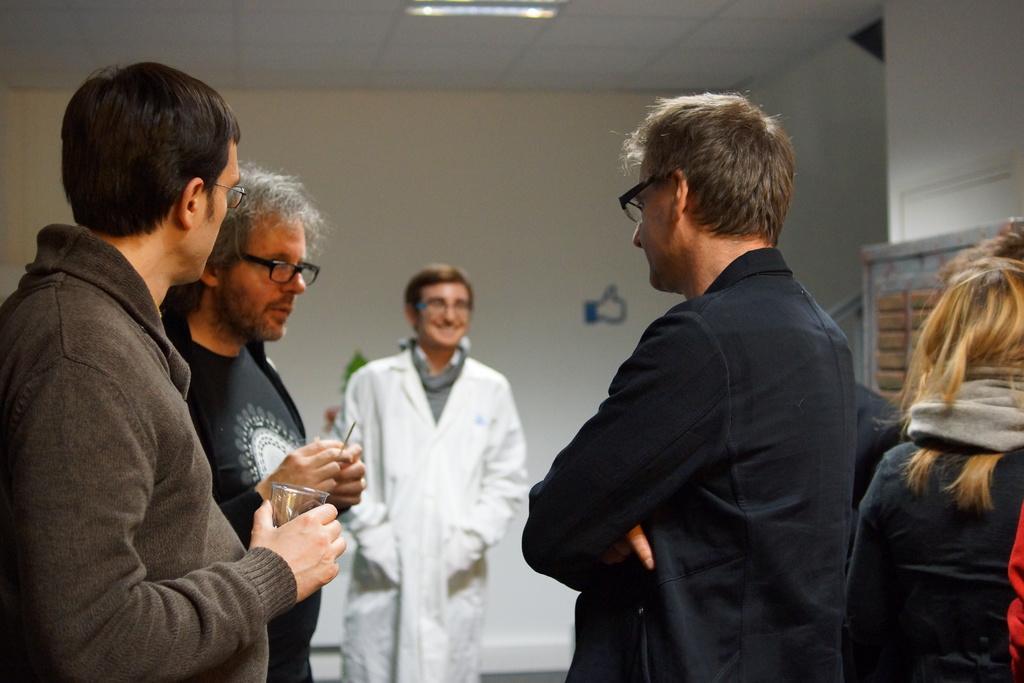Please provide a concise description of this image. In this image, we can see people standing and wearing glasses and some of them are holding objects in their hands. In the background, there is a wall and at the top, there is a light and a roof. 